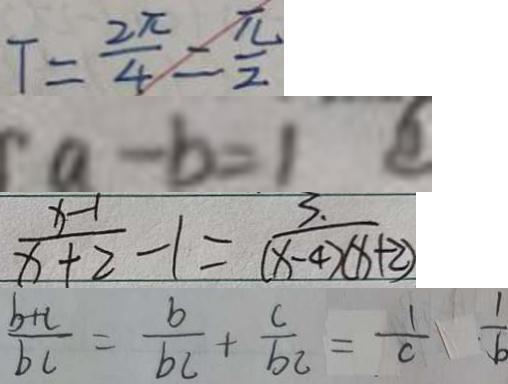<formula> <loc_0><loc_0><loc_500><loc_500>T = \frac { 2 \pi } { 4 } = \frac { \pi } { 2 } 
 a - b = 1 
 \frac { x - 1 } { x + 2 } - 1 = \frac { 3 . } { ( x - 4 ) ( x + 2 ) } 
 \frac { b + c } { b c } = \frac { b } { b c } + \frac { c } { b c } = \frac { 1 } { c } \frac { 1 } { b }</formula> 